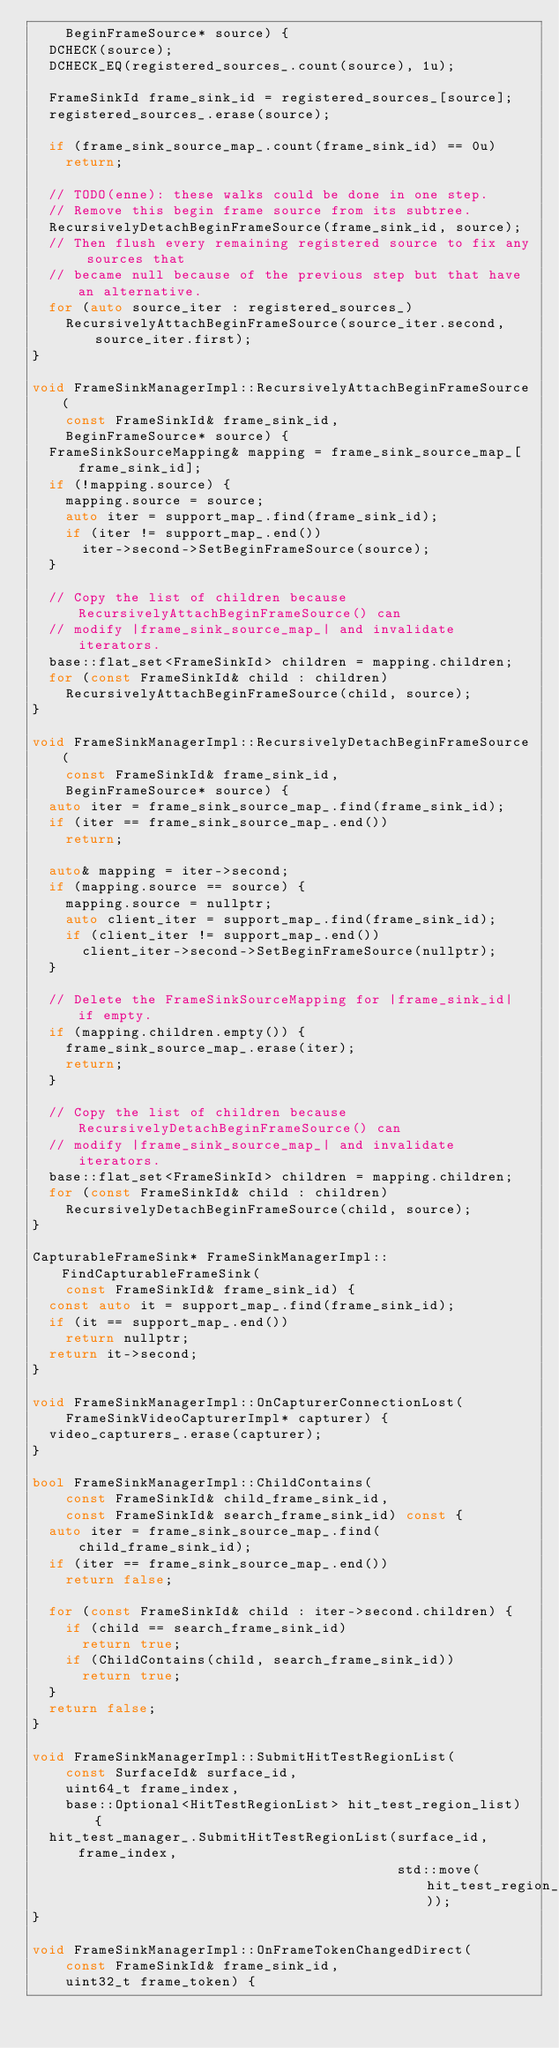Convert code to text. <code><loc_0><loc_0><loc_500><loc_500><_C++_>    BeginFrameSource* source) {
  DCHECK(source);
  DCHECK_EQ(registered_sources_.count(source), 1u);

  FrameSinkId frame_sink_id = registered_sources_[source];
  registered_sources_.erase(source);

  if (frame_sink_source_map_.count(frame_sink_id) == 0u)
    return;

  // TODO(enne): these walks could be done in one step.
  // Remove this begin frame source from its subtree.
  RecursivelyDetachBeginFrameSource(frame_sink_id, source);
  // Then flush every remaining registered source to fix any sources that
  // became null because of the previous step but that have an alternative.
  for (auto source_iter : registered_sources_)
    RecursivelyAttachBeginFrameSource(source_iter.second, source_iter.first);
}

void FrameSinkManagerImpl::RecursivelyAttachBeginFrameSource(
    const FrameSinkId& frame_sink_id,
    BeginFrameSource* source) {
  FrameSinkSourceMapping& mapping = frame_sink_source_map_[frame_sink_id];
  if (!mapping.source) {
    mapping.source = source;
    auto iter = support_map_.find(frame_sink_id);
    if (iter != support_map_.end())
      iter->second->SetBeginFrameSource(source);
  }

  // Copy the list of children because RecursivelyAttachBeginFrameSource() can
  // modify |frame_sink_source_map_| and invalidate iterators.
  base::flat_set<FrameSinkId> children = mapping.children;
  for (const FrameSinkId& child : children)
    RecursivelyAttachBeginFrameSource(child, source);
}

void FrameSinkManagerImpl::RecursivelyDetachBeginFrameSource(
    const FrameSinkId& frame_sink_id,
    BeginFrameSource* source) {
  auto iter = frame_sink_source_map_.find(frame_sink_id);
  if (iter == frame_sink_source_map_.end())
    return;

  auto& mapping = iter->second;
  if (mapping.source == source) {
    mapping.source = nullptr;
    auto client_iter = support_map_.find(frame_sink_id);
    if (client_iter != support_map_.end())
      client_iter->second->SetBeginFrameSource(nullptr);
  }

  // Delete the FrameSinkSourceMapping for |frame_sink_id| if empty.
  if (mapping.children.empty()) {
    frame_sink_source_map_.erase(iter);
    return;
  }

  // Copy the list of children because RecursivelyDetachBeginFrameSource() can
  // modify |frame_sink_source_map_| and invalidate iterators.
  base::flat_set<FrameSinkId> children = mapping.children;
  for (const FrameSinkId& child : children)
    RecursivelyDetachBeginFrameSource(child, source);
}

CapturableFrameSink* FrameSinkManagerImpl::FindCapturableFrameSink(
    const FrameSinkId& frame_sink_id) {
  const auto it = support_map_.find(frame_sink_id);
  if (it == support_map_.end())
    return nullptr;
  return it->second;
}

void FrameSinkManagerImpl::OnCapturerConnectionLost(
    FrameSinkVideoCapturerImpl* capturer) {
  video_capturers_.erase(capturer);
}

bool FrameSinkManagerImpl::ChildContains(
    const FrameSinkId& child_frame_sink_id,
    const FrameSinkId& search_frame_sink_id) const {
  auto iter = frame_sink_source_map_.find(child_frame_sink_id);
  if (iter == frame_sink_source_map_.end())
    return false;

  for (const FrameSinkId& child : iter->second.children) {
    if (child == search_frame_sink_id)
      return true;
    if (ChildContains(child, search_frame_sink_id))
      return true;
  }
  return false;
}

void FrameSinkManagerImpl::SubmitHitTestRegionList(
    const SurfaceId& surface_id,
    uint64_t frame_index,
    base::Optional<HitTestRegionList> hit_test_region_list) {
  hit_test_manager_.SubmitHitTestRegionList(surface_id, frame_index,
                                            std::move(hit_test_region_list));
}

void FrameSinkManagerImpl::OnFrameTokenChangedDirect(
    const FrameSinkId& frame_sink_id,
    uint32_t frame_token) {</code> 